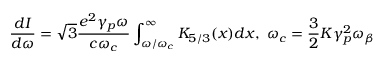Convert formula to latex. <formula><loc_0><loc_0><loc_500><loc_500>\frac { d I } { d \omega } = \sqrt { 3 } \frac { e ^ { 2 } \gamma _ { p } \omega } { c \omega _ { c } } \int _ { \omega / \omega _ { c } } ^ { \infty } K _ { 5 / 3 } ( x ) d x , \, \omega _ { c } = \frac { 3 } { 2 } K \gamma _ { p } ^ { 2 } \omega _ { \beta }</formula> 